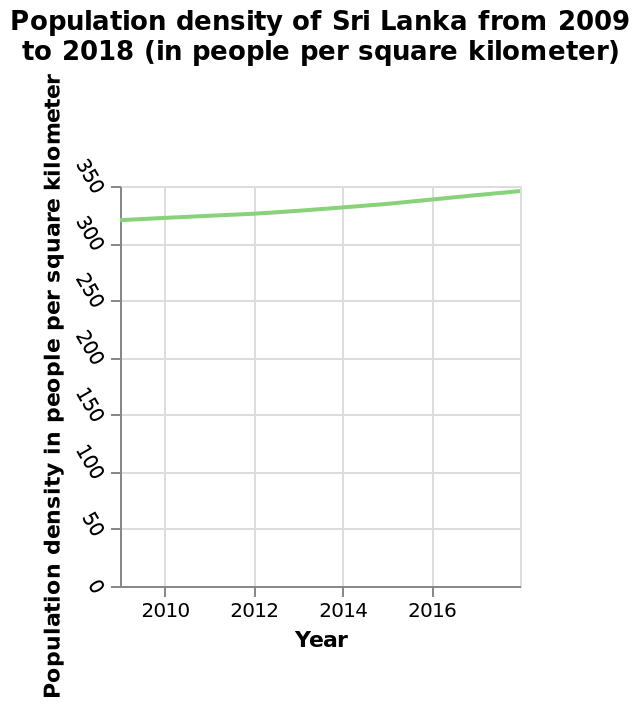<image>
What does the y-axis represent on the line plot?  The y-axis represents the population density in people per square kilometer. 